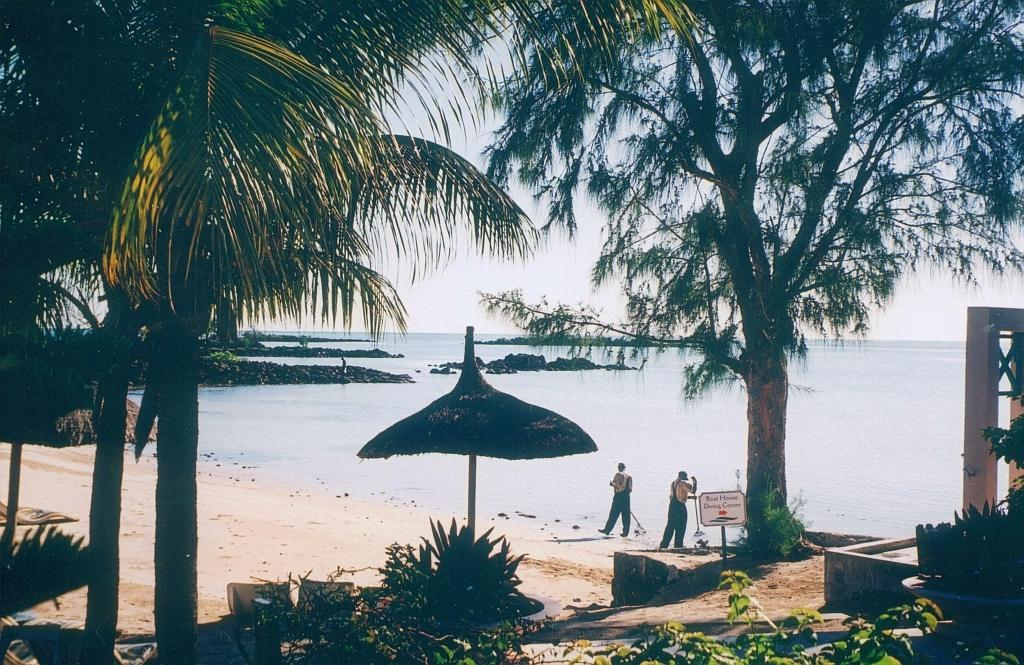What type of location is depicted in the image? There is a beach in the image. What natural elements can be seen on the beach? There are trees on the beach. What type of structure is present on the beach? There is a shelter on the beach. What are the people in the image doing? Two people are walking on the beach. What can be seen in the distance behind the beach? The sea is visible in the background of the image. What type of produce is being sold by the zebra on the beach? There is no zebra present in the image, and therefore no produce is being sold. 